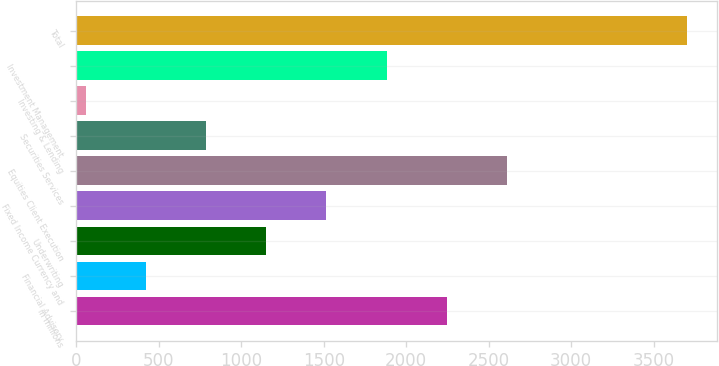Convert chart to OTSL. <chart><loc_0><loc_0><loc_500><loc_500><bar_chart><fcel>in millions<fcel>Financial Advisory<fcel>Underwriting<fcel>Fixed Income Currency and<fcel>Equities Client Execution<fcel>Securities Services<fcel>Investing & Lending<fcel>Investment Management<fcel>Total<nl><fcel>2244.8<fcel>423.3<fcel>1151.9<fcel>1516.2<fcel>2609.1<fcel>787.6<fcel>59<fcel>1880.5<fcel>3702<nl></chart> 